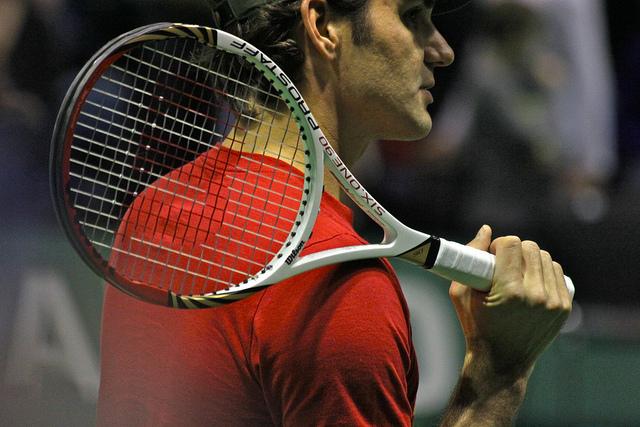What is the man holding?
Write a very short answer. Tennis racket. Is the man a tennis legend?
Give a very brief answer. Yes. What color is the man's shirt?
Concise answer only. Red. 